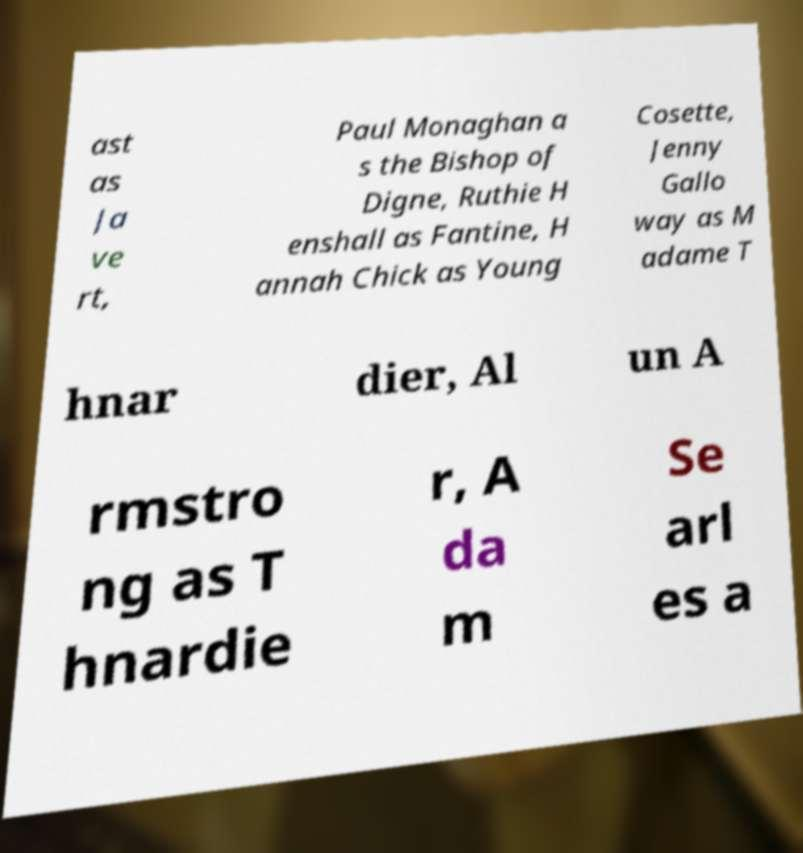There's text embedded in this image that I need extracted. Can you transcribe it verbatim? ast as Ja ve rt, Paul Monaghan a s the Bishop of Digne, Ruthie H enshall as Fantine, H annah Chick as Young Cosette, Jenny Gallo way as M adame T hnar dier, Al un A rmstro ng as T hnardie r, A da m Se arl es a 